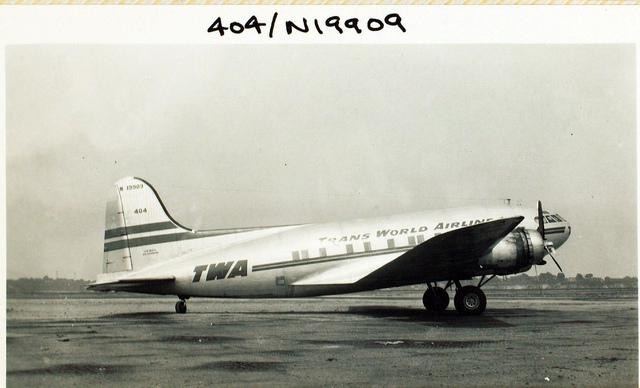Is this a modern jet?
Answer briefly. No. What number and letters are written on the photo?
Answer briefly. 404n19909. What airline logo is on the side of the jet?
Concise answer only. Twa. 